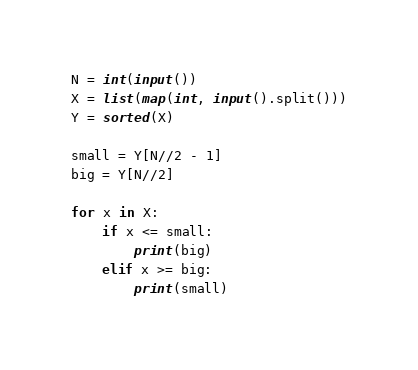<code> <loc_0><loc_0><loc_500><loc_500><_Python_>N = int(input())
X = list(map(int, input().split()))
Y = sorted(X)

small = Y[N//2 - 1]
big = Y[N//2]

for x in X:
    if x <= small:
        print(big)
    elif x >= big:
        print(small)
</code> 